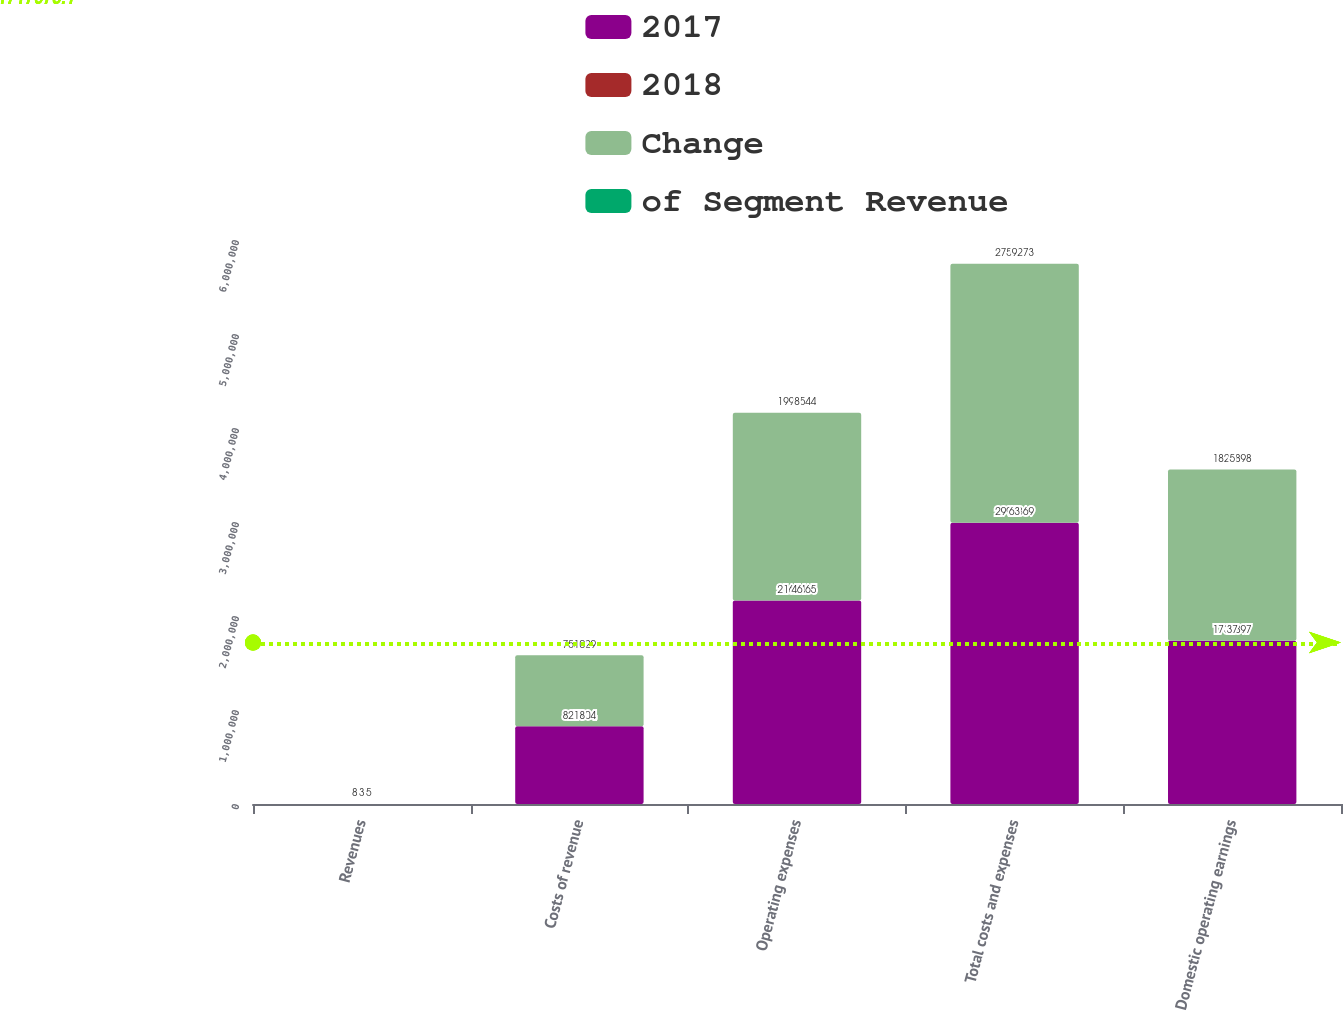<chart> <loc_0><loc_0><loc_500><loc_500><stacked_bar_chart><ecel><fcel>Revenues<fcel>Costs of revenue<fcel>Operating expenses<fcel>Total costs and expenses<fcel>Domestic operating earnings<nl><fcel>2017<fcel>81.5<fcel>827904<fcel>2.16446e+06<fcel>2.99237e+06<fcel>1.7379e+06<nl><fcel>2018<fcel>100<fcel>18<fcel>46<fcel>63<fcel>37<nl><fcel>Change<fcel>81.5<fcel>755729<fcel>1.99854e+06<fcel>2.75427e+06<fcel>1.8209e+06<nl><fcel>of Segment Revenue<fcel>3<fcel>10<fcel>8<fcel>9<fcel>5<nl></chart> 